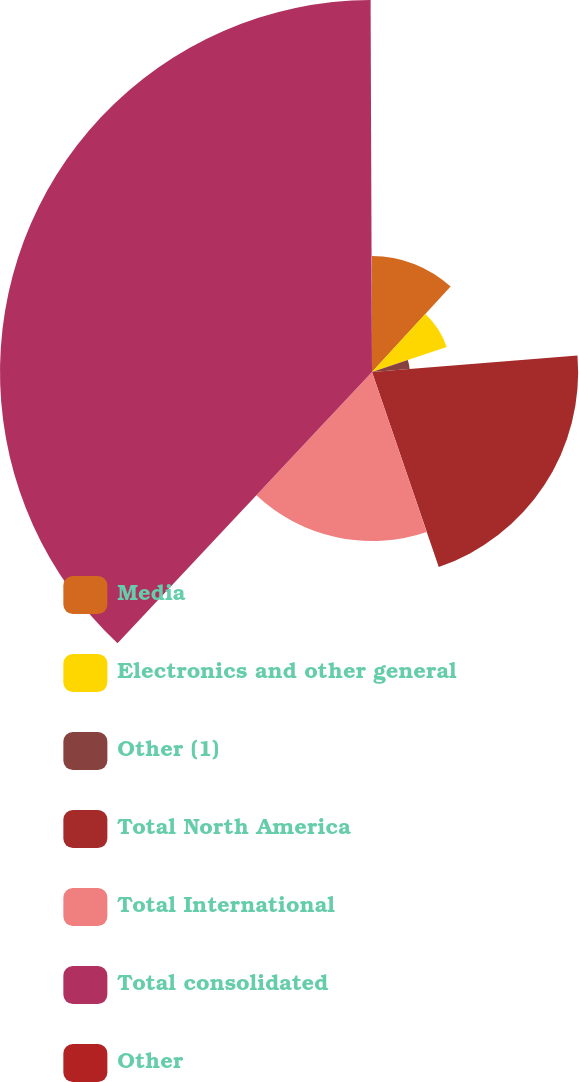Convert chart to OTSL. <chart><loc_0><loc_0><loc_500><loc_500><pie_chart><fcel>Media<fcel>Electronics and other general<fcel>Other (1)<fcel>Total North America<fcel>Total International<fcel>Total consolidated<fcel>Other<nl><fcel>11.84%<fcel>8.03%<fcel>3.85%<fcel>21.03%<fcel>17.24%<fcel>37.95%<fcel>0.06%<nl></chart> 